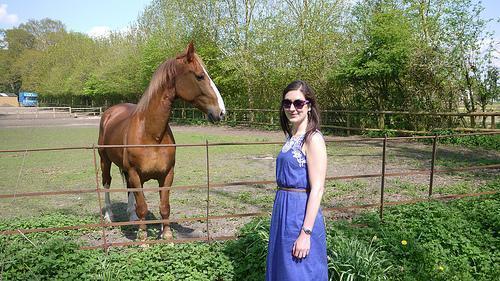How many horses are pictured?
Give a very brief answer. 1. How many sheep dogs are behind the horse?
Give a very brief answer. 0. 